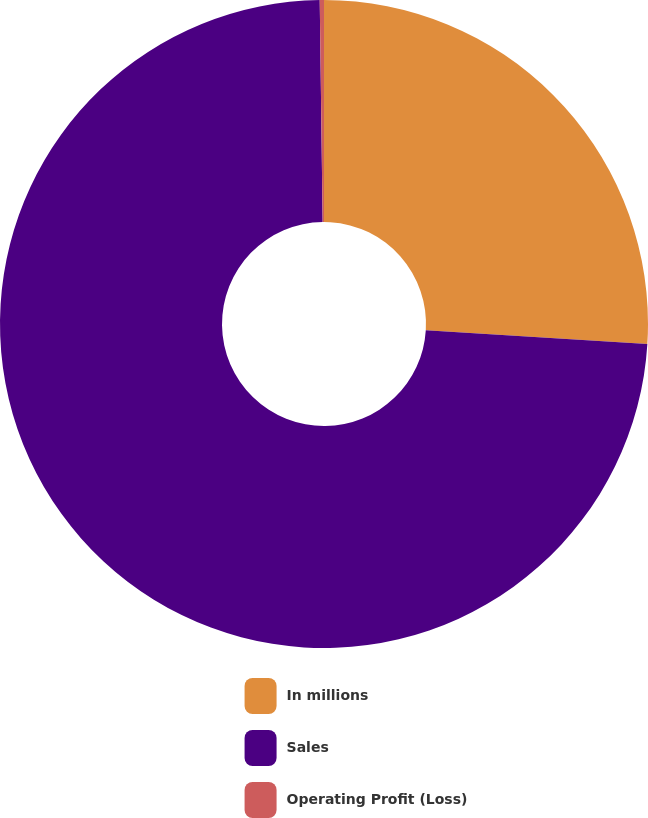Convert chart. <chart><loc_0><loc_0><loc_500><loc_500><pie_chart><fcel>In millions<fcel>Sales<fcel>Operating Profit (Loss)<nl><fcel>25.99%<fcel>73.81%<fcel>0.21%<nl></chart> 